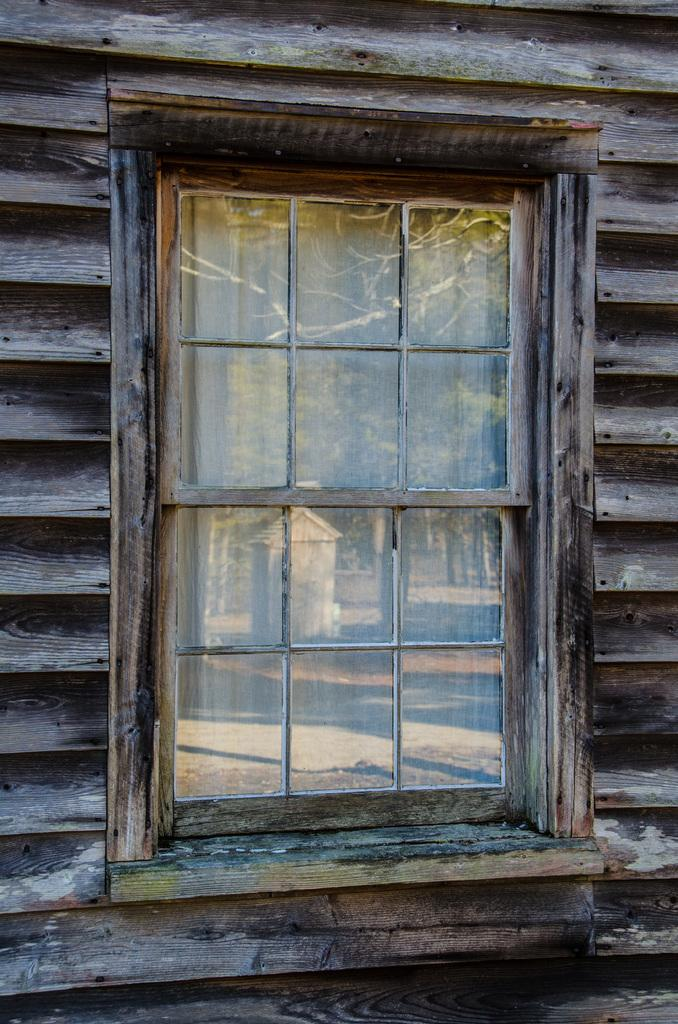What can be seen in the image that provides a view of the outdoors? There is a window in the image that provides a view of the outdoors. What type of vegetation is visible in the image? There is grass visible in the image. What is reflected in the window? There is a reflection from the window in the image. What can be seen through the window? Trees are visible from the window in the image. What type of toys are being adjusted by the head in the image? There is no head or toys present in the image. 